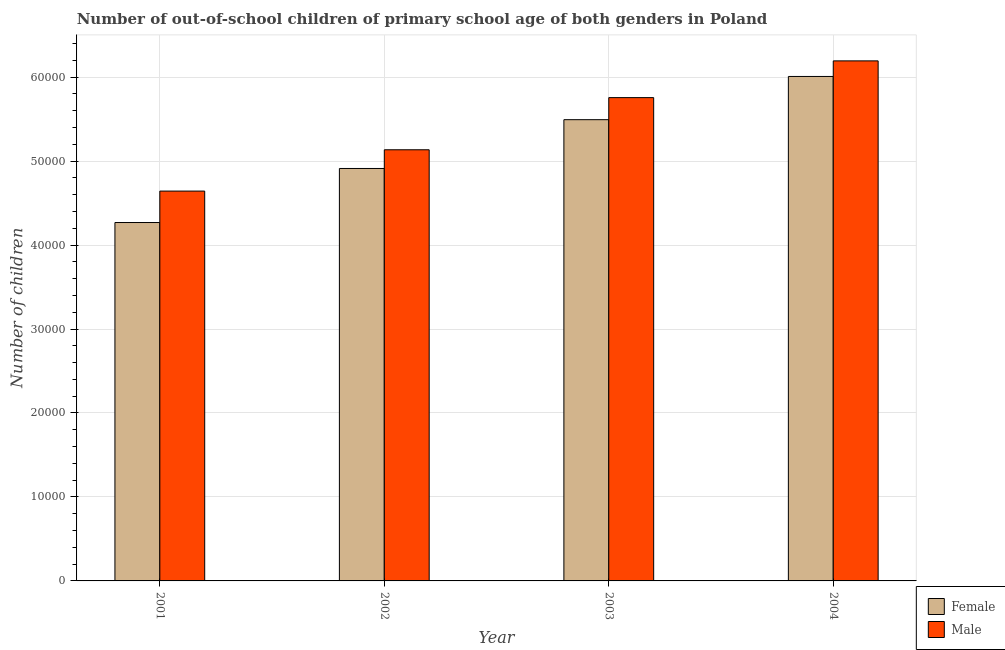How many groups of bars are there?
Keep it short and to the point. 4. Are the number of bars per tick equal to the number of legend labels?
Make the answer very short. Yes. How many bars are there on the 1st tick from the left?
Offer a terse response. 2. How many bars are there on the 4th tick from the right?
Offer a terse response. 2. In how many cases, is the number of bars for a given year not equal to the number of legend labels?
Your response must be concise. 0. What is the number of female out-of-school students in 2002?
Keep it short and to the point. 4.91e+04. Across all years, what is the maximum number of female out-of-school students?
Your response must be concise. 6.01e+04. Across all years, what is the minimum number of male out-of-school students?
Your answer should be compact. 4.64e+04. In which year was the number of male out-of-school students maximum?
Ensure brevity in your answer.  2004. In which year was the number of male out-of-school students minimum?
Your response must be concise. 2001. What is the total number of female out-of-school students in the graph?
Give a very brief answer. 2.07e+05. What is the difference between the number of male out-of-school students in 2002 and that in 2003?
Your response must be concise. -6212. What is the difference between the number of female out-of-school students in 2004 and the number of male out-of-school students in 2002?
Give a very brief answer. 1.10e+04. What is the average number of male out-of-school students per year?
Offer a very short reply. 5.43e+04. What is the ratio of the number of female out-of-school students in 2002 to that in 2004?
Ensure brevity in your answer.  0.82. Is the number of male out-of-school students in 2002 less than that in 2003?
Offer a terse response. Yes. What is the difference between the highest and the second highest number of male out-of-school students?
Ensure brevity in your answer.  4376. What is the difference between the highest and the lowest number of male out-of-school students?
Provide a succinct answer. 1.55e+04. Are all the bars in the graph horizontal?
Keep it short and to the point. No. Are the values on the major ticks of Y-axis written in scientific E-notation?
Provide a succinct answer. No. How many legend labels are there?
Offer a very short reply. 2. How are the legend labels stacked?
Keep it short and to the point. Vertical. What is the title of the graph?
Keep it short and to the point. Number of out-of-school children of primary school age of both genders in Poland. Does "% of gross capital formation" appear as one of the legend labels in the graph?
Offer a very short reply. No. What is the label or title of the X-axis?
Your answer should be compact. Year. What is the label or title of the Y-axis?
Offer a terse response. Number of children. What is the Number of children in Female in 2001?
Provide a succinct answer. 4.27e+04. What is the Number of children of Male in 2001?
Your answer should be very brief. 4.64e+04. What is the Number of children of Female in 2002?
Offer a very short reply. 4.91e+04. What is the Number of children in Male in 2002?
Your answer should be very brief. 5.14e+04. What is the Number of children in Female in 2003?
Keep it short and to the point. 5.49e+04. What is the Number of children in Male in 2003?
Your answer should be very brief. 5.76e+04. What is the Number of children of Female in 2004?
Provide a succinct answer. 6.01e+04. What is the Number of children of Male in 2004?
Provide a succinct answer. 6.19e+04. Across all years, what is the maximum Number of children of Female?
Make the answer very short. 6.01e+04. Across all years, what is the maximum Number of children of Male?
Ensure brevity in your answer.  6.19e+04. Across all years, what is the minimum Number of children in Female?
Provide a short and direct response. 4.27e+04. Across all years, what is the minimum Number of children of Male?
Your answer should be compact. 4.64e+04. What is the total Number of children in Female in the graph?
Your answer should be compact. 2.07e+05. What is the total Number of children in Male in the graph?
Offer a very short reply. 2.17e+05. What is the difference between the Number of children of Female in 2001 and that in 2002?
Provide a succinct answer. -6436. What is the difference between the Number of children in Male in 2001 and that in 2002?
Your response must be concise. -4920. What is the difference between the Number of children in Female in 2001 and that in 2003?
Provide a short and direct response. -1.22e+04. What is the difference between the Number of children in Male in 2001 and that in 2003?
Provide a short and direct response. -1.11e+04. What is the difference between the Number of children of Female in 2001 and that in 2004?
Keep it short and to the point. -1.74e+04. What is the difference between the Number of children in Male in 2001 and that in 2004?
Provide a succinct answer. -1.55e+04. What is the difference between the Number of children in Female in 2002 and that in 2003?
Your response must be concise. -5813. What is the difference between the Number of children of Male in 2002 and that in 2003?
Keep it short and to the point. -6212. What is the difference between the Number of children in Female in 2002 and that in 2004?
Make the answer very short. -1.10e+04. What is the difference between the Number of children in Male in 2002 and that in 2004?
Your answer should be compact. -1.06e+04. What is the difference between the Number of children of Female in 2003 and that in 2004?
Offer a very short reply. -5147. What is the difference between the Number of children in Male in 2003 and that in 2004?
Your response must be concise. -4376. What is the difference between the Number of children in Female in 2001 and the Number of children in Male in 2002?
Offer a very short reply. -8664. What is the difference between the Number of children of Female in 2001 and the Number of children of Male in 2003?
Offer a very short reply. -1.49e+04. What is the difference between the Number of children of Female in 2001 and the Number of children of Male in 2004?
Your answer should be very brief. -1.93e+04. What is the difference between the Number of children in Female in 2002 and the Number of children in Male in 2003?
Your response must be concise. -8440. What is the difference between the Number of children of Female in 2002 and the Number of children of Male in 2004?
Keep it short and to the point. -1.28e+04. What is the difference between the Number of children in Female in 2003 and the Number of children in Male in 2004?
Your answer should be compact. -7003. What is the average Number of children of Female per year?
Keep it short and to the point. 5.17e+04. What is the average Number of children of Male per year?
Your answer should be very brief. 5.43e+04. In the year 2001, what is the difference between the Number of children in Female and Number of children in Male?
Your answer should be compact. -3744. In the year 2002, what is the difference between the Number of children in Female and Number of children in Male?
Provide a succinct answer. -2228. In the year 2003, what is the difference between the Number of children of Female and Number of children of Male?
Give a very brief answer. -2627. In the year 2004, what is the difference between the Number of children in Female and Number of children in Male?
Your answer should be compact. -1856. What is the ratio of the Number of children in Female in 2001 to that in 2002?
Offer a terse response. 0.87. What is the ratio of the Number of children in Male in 2001 to that in 2002?
Give a very brief answer. 0.9. What is the ratio of the Number of children of Female in 2001 to that in 2003?
Offer a terse response. 0.78. What is the ratio of the Number of children of Male in 2001 to that in 2003?
Offer a very short reply. 0.81. What is the ratio of the Number of children of Female in 2001 to that in 2004?
Make the answer very short. 0.71. What is the ratio of the Number of children of Male in 2001 to that in 2004?
Make the answer very short. 0.75. What is the ratio of the Number of children of Female in 2002 to that in 2003?
Your answer should be compact. 0.89. What is the ratio of the Number of children of Male in 2002 to that in 2003?
Offer a terse response. 0.89. What is the ratio of the Number of children in Female in 2002 to that in 2004?
Your answer should be compact. 0.82. What is the ratio of the Number of children in Male in 2002 to that in 2004?
Offer a terse response. 0.83. What is the ratio of the Number of children in Female in 2003 to that in 2004?
Offer a very short reply. 0.91. What is the ratio of the Number of children of Male in 2003 to that in 2004?
Offer a very short reply. 0.93. What is the difference between the highest and the second highest Number of children in Female?
Keep it short and to the point. 5147. What is the difference between the highest and the second highest Number of children in Male?
Provide a succinct answer. 4376. What is the difference between the highest and the lowest Number of children of Female?
Offer a very short reply. 1.74e+04. What is the difference between the highest and the lowest Number of children in Male?
Offer a very short reply. 1.55e+04. 